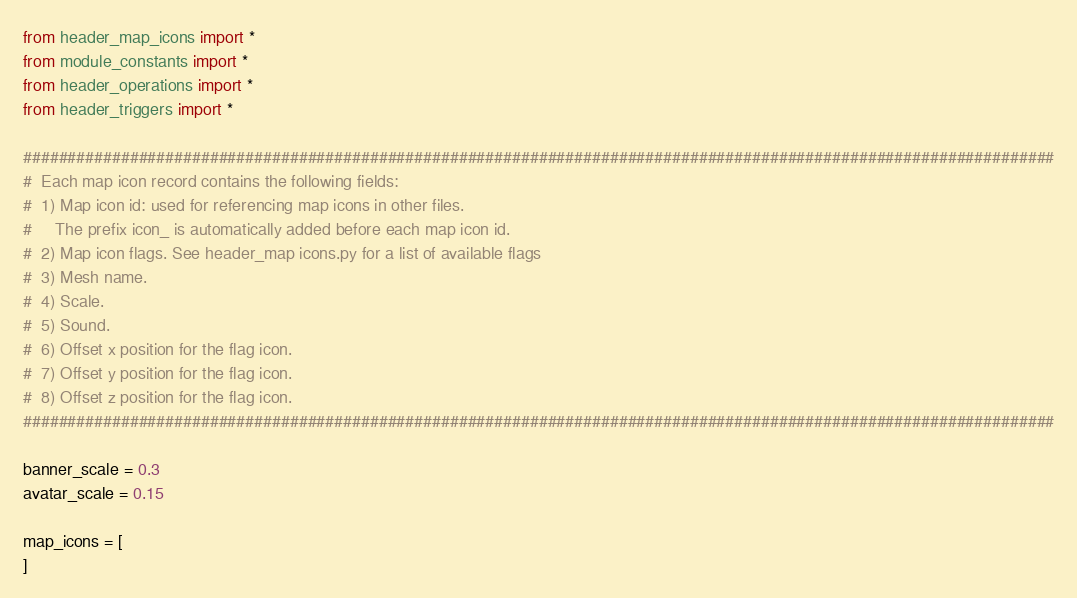Convert code to text. <code><loc_0><loc_0><loc_500><loc_500><_Python_>from header_map_icons import *
from module_constants import *
from header_operations import *
from header_triggers import *

####################################################################################################################
#  Each map icon record contains the following fields:
#  1) Map icon id: used for referencing map icons in other files.
#     The prefix icon_ is automatically added before each map icon id.
#  2) Map icon flags. See header_map icons.py for a list of available flags
#  3) Mesh name.
#  4) Scale.
#  5) Sound.
#  6) Offset x position for the flag icon.
#  7) Offset y position for the flag icon.
#  8) Offset z position for the flag icon.
####################################################################################################################

banner_scale = 0.3
avatar_scale = 0.15

map_icons = [
]
</code> 